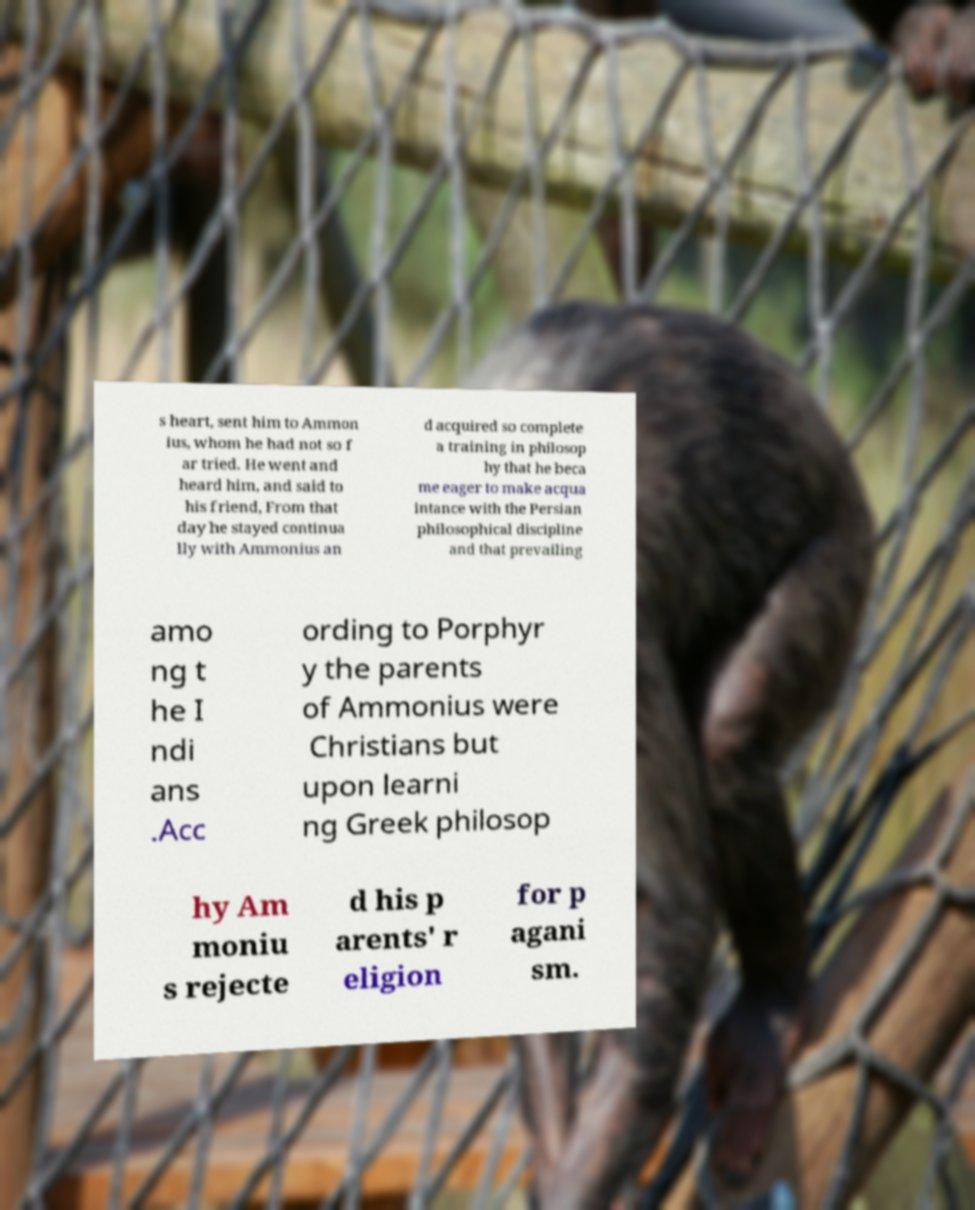Can you read and provide the text displayed in the image?This photo seems to have some interesting text. Can you extract and type it out for me? s heart, sent him to Ammon ius, whom he had not so f ar tried. He went and heard him, and said to his friend, From that day he stayed continua lly with Ammonius an d acquired so complete a training in philosop hy that he beca me eager to make acqua intance with the Persian philosophical discipline and that prevailing amo ng t he I ndi ans .Acc ording to Porphyr y the parents of Ammonius were Christians but upon learni ng Greek philosop hy Am moniu s rejecte d his p arents' r eligion for p agani sm. 